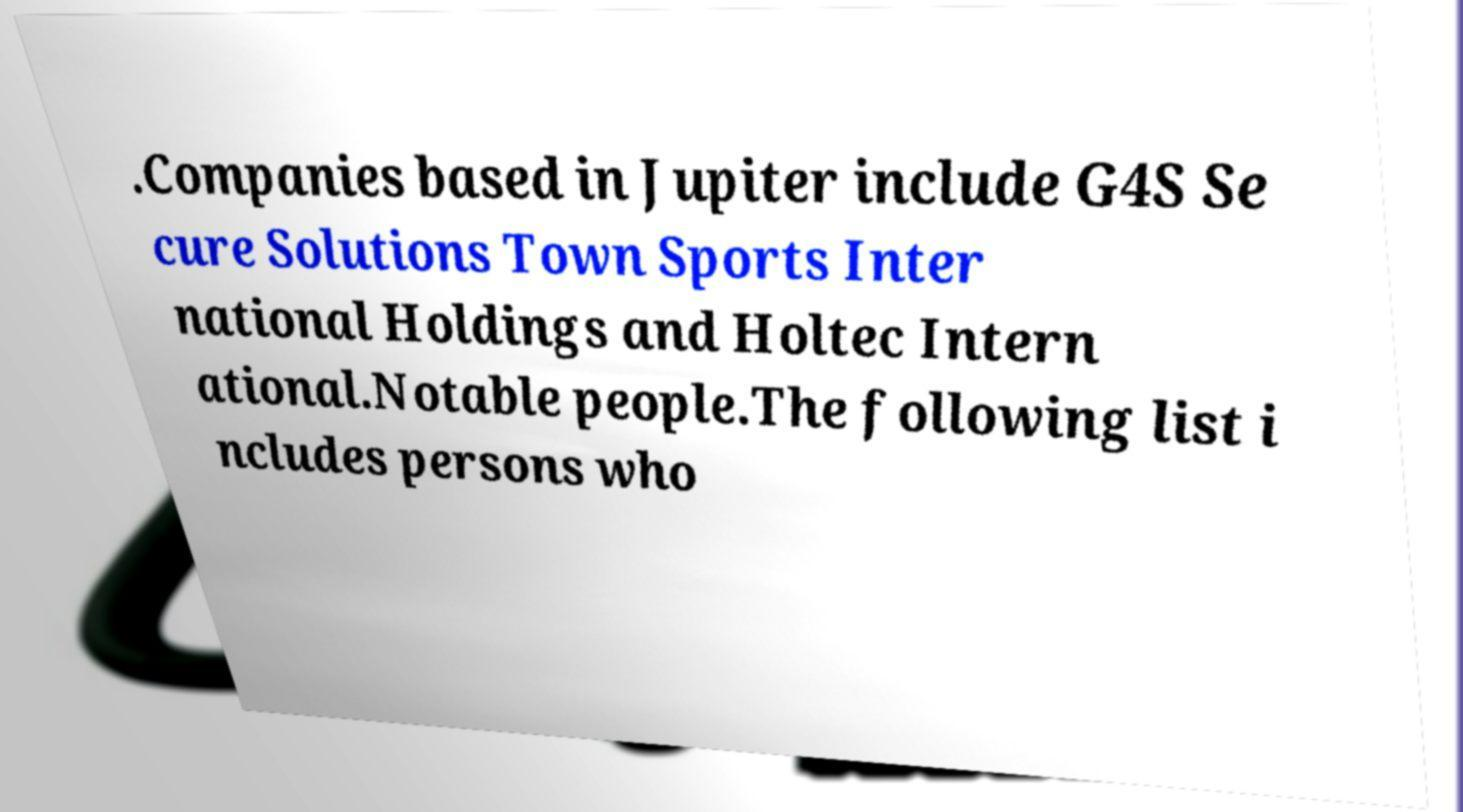Can you read and provide the text displayed in the image?This photo seems to have some interesting text. Can you extract and type it out for me? .Companies based in Jupiter include G4S Se cure Solutions Town Sports Inter national Holdings and Holtec Intern ational.Notable people.The following list i ncludes persons who 